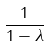<formula> <loc_0><loc_0><loc_500><loc_500>\frac { 1 } { 1 - \lambda }</formula> 